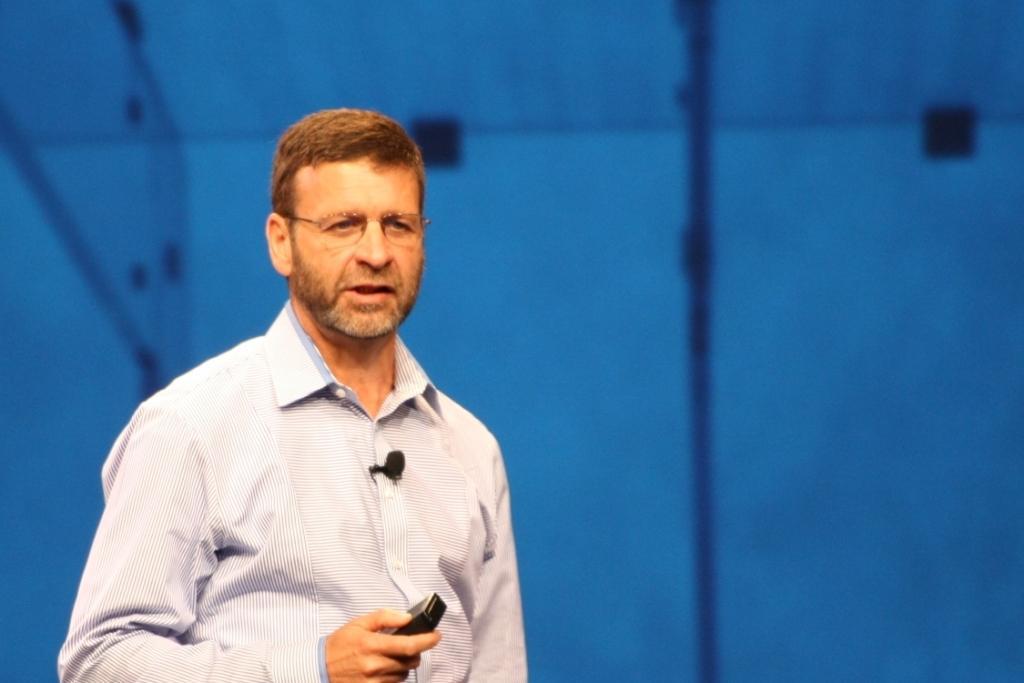Can you describe this image briefly? In this picture I can see there is a man standing and he is holding a remote in his right hand and there is a blue surface in the backdrop. 